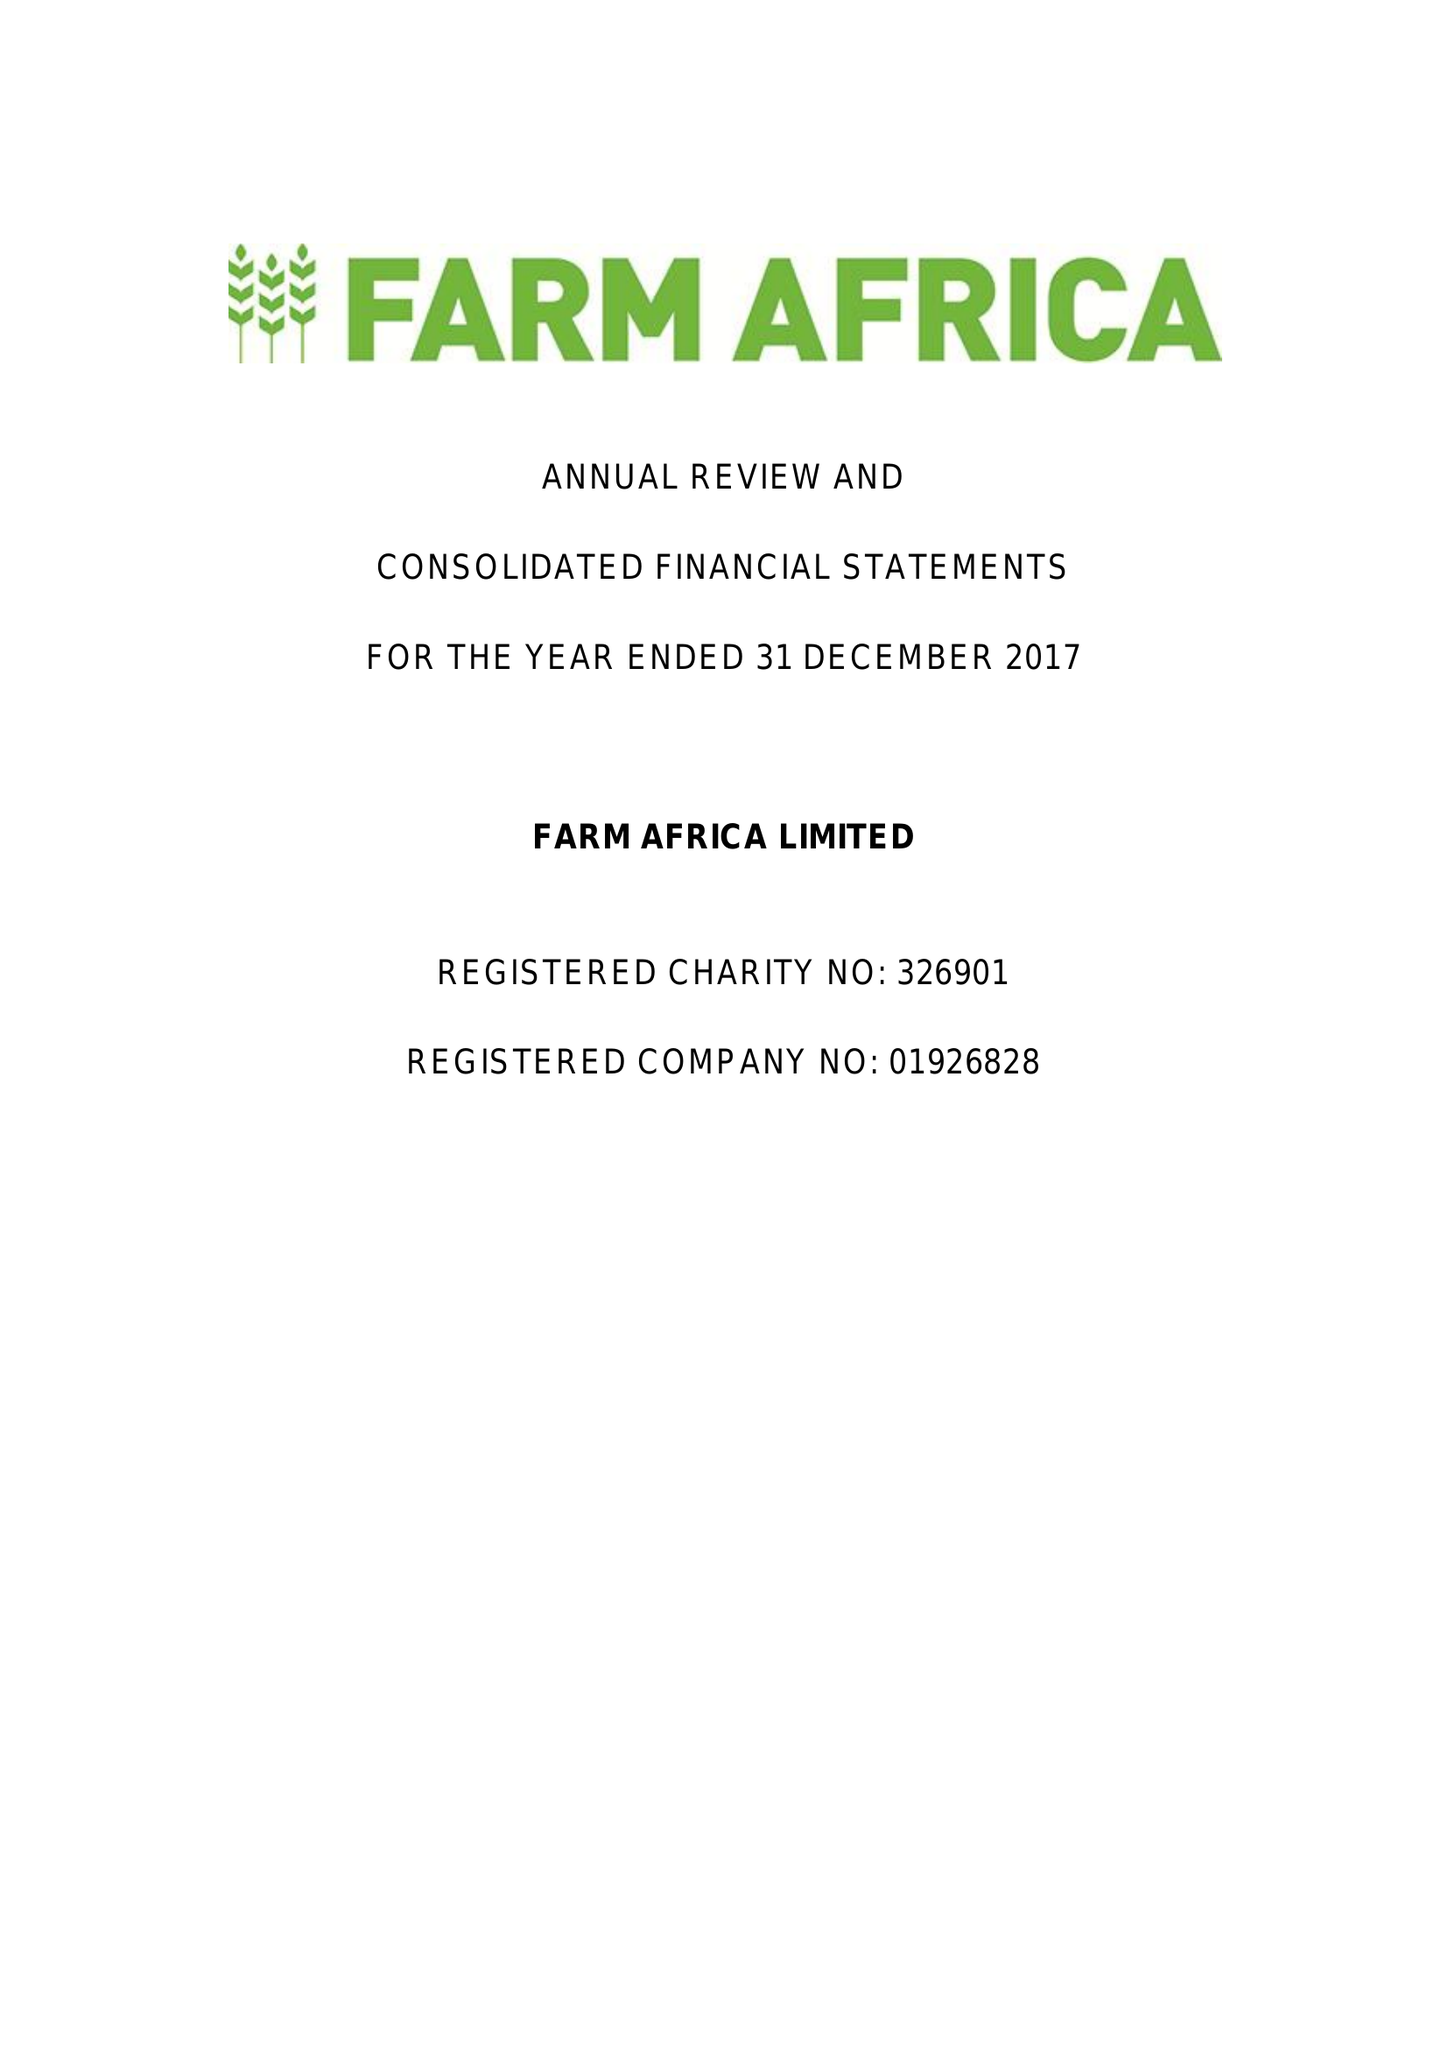What is the value for the charity_name?
Answer the question using a single word or phrase. Farm Africa Ltd. 